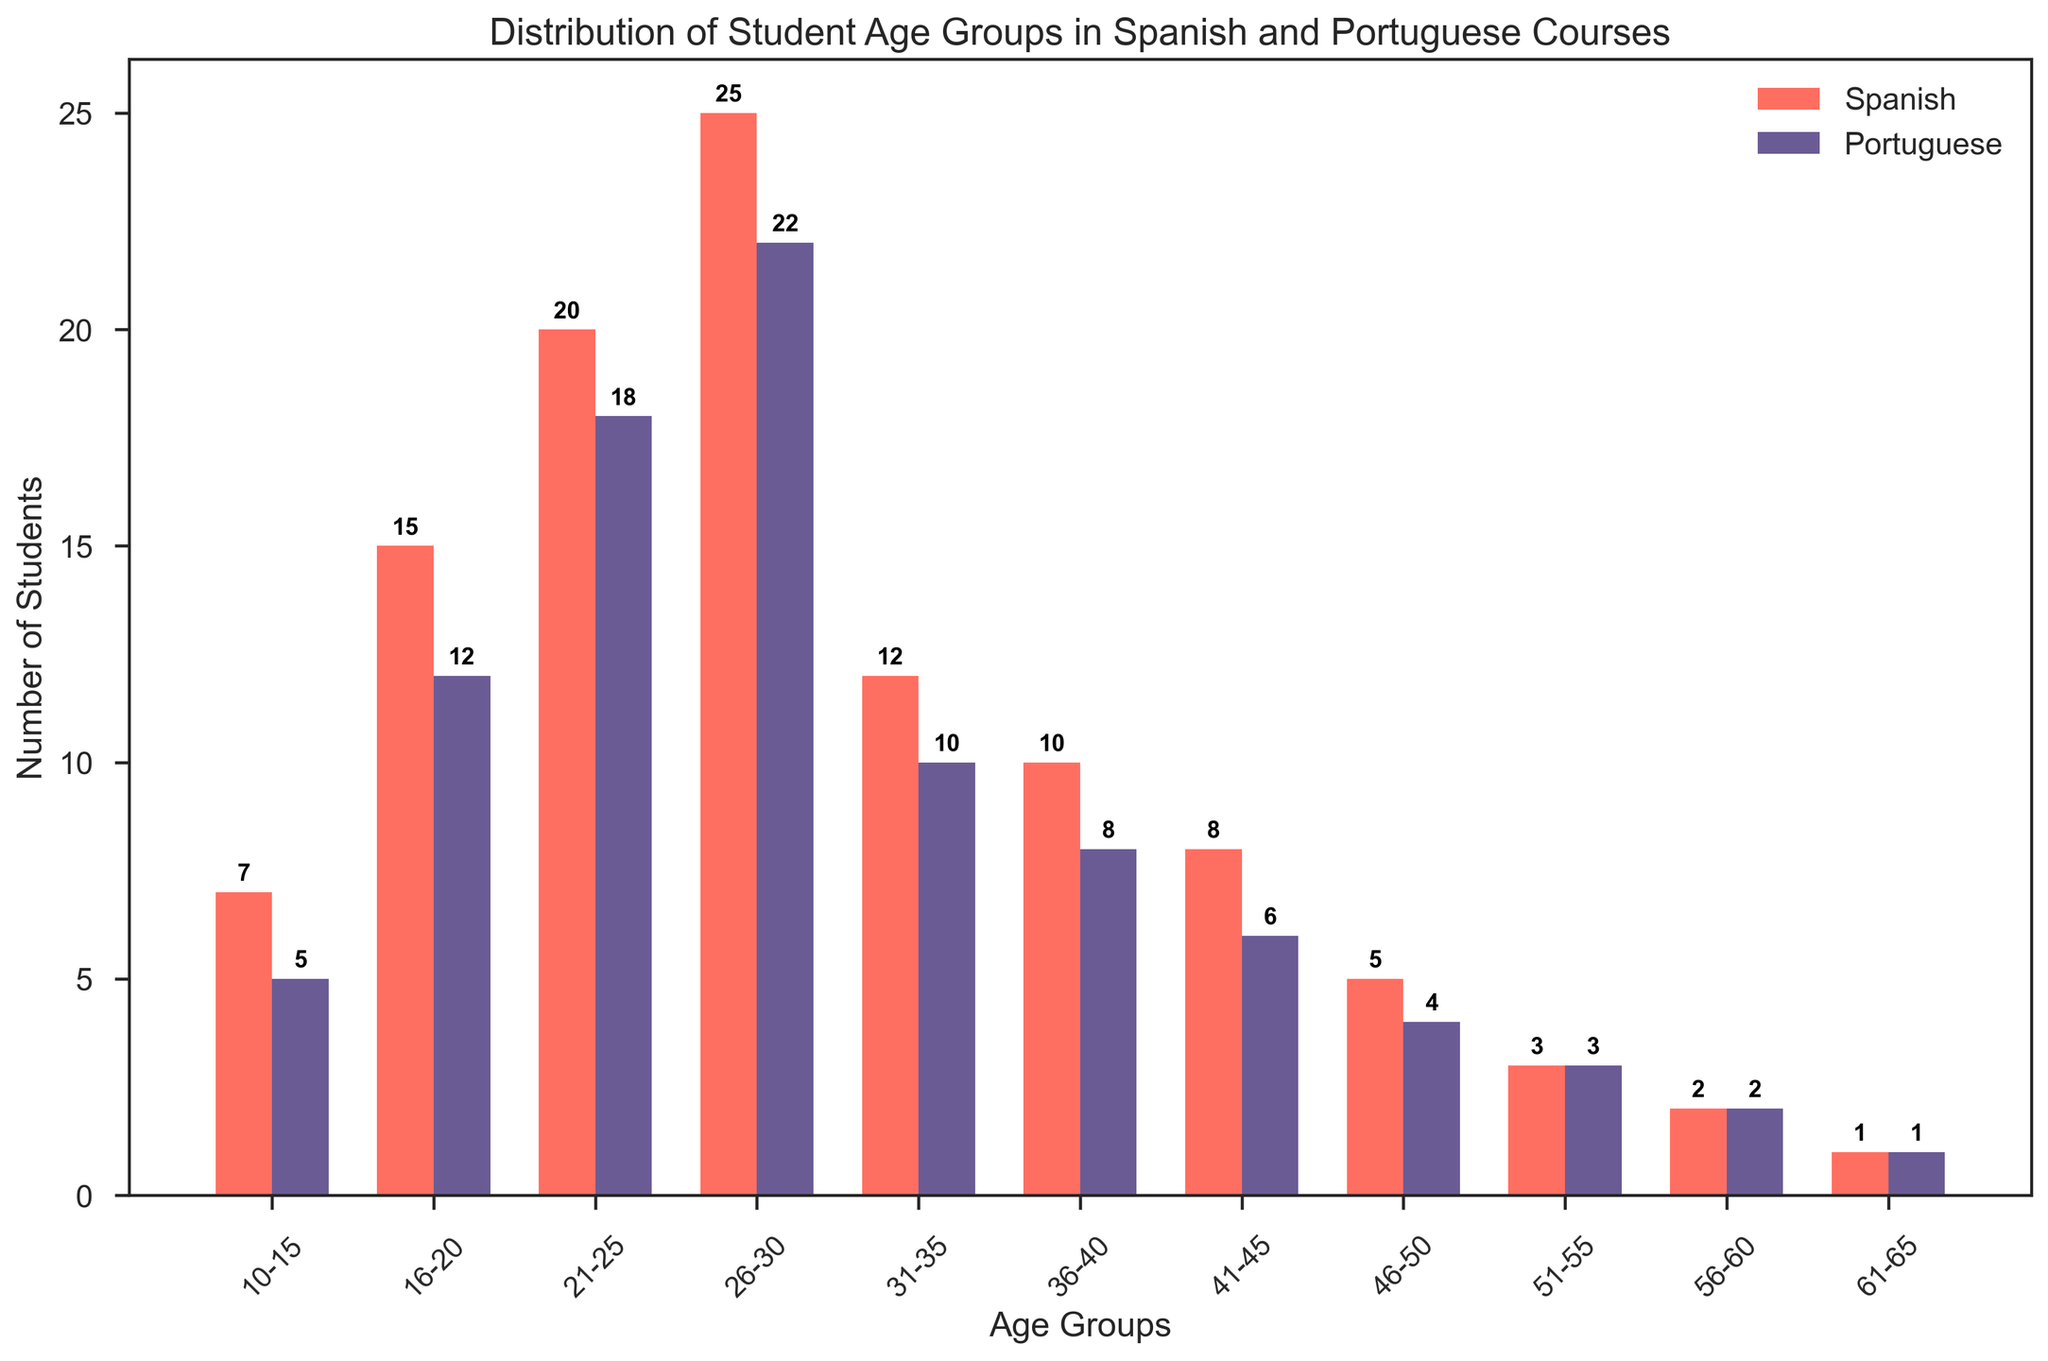Which age group has the highest number of students for Spanish courses? From the figure, the age group 26-30 has the highest bar among all the age groups for Spanish courses.
Answer: 26-30 Which age group has the highest number of students for Portuguese courses? From the figure, the age group 26-30 has the highest bar among all the age groups for Portuguese courses.
Answer: 26-30 Which age group has the smallest difference in the number of students between Spanish and Portuguese courses? From the figure, we check the height of the bars for both languages in each age group and find that the age group 56-60 has the smallest difference (both have 2 students).
Answer: 56-60 What is the total number of students enrolled in the age group 16-20 for both Spanish and Portuguese courses? Adding the number of students from both courses in the age group 16-20: 15 (Spanish) + 12 (Portuguese) = 27.
Answer: 27 Which age group shows the most dissimilarity in the number of students between the Spanish and Portuguese courses? By looking at the figure, the age group 26-30 has the largest difference, with Spanish (25 students) and Portuguese (22 students) having the highest and second-highest counts respectively.
Answer: 26-30 For which age groups do Spanish courses have more students than Portuguese courses? Spanish courses have more students than Portuguese in the following age groups: 10-15, 16-20, 21-25, 26-30, 31-35, 36-40, 41-45, and 46-50. This is inferred from their bars being taller.
Answer: 10-15, 16-20, 21-25, 26-30, 31-35, 36-40, 41-45, 46-50 What is the sum of students in Spanish courses across all age groups? Summing the number of students in Spanish courses across all age groups (7 + 15 + 20 + 25 + 12 + 10 + 8 + 5 + 3 + 2 + 1) = 108.
Answer: 108 What is the difference in the number of students between Spanish and Portuguese courses in the age group 31-35? Subtracting the number of Portuguese students from the Spanish students in the age group 31-35: 12 (Spanish) - 10 (Portuguese) = 2.
Answer: 2 Which language course has the overall higher enrollment in the age group 26-30? By comparing the heights of the bars, Spanish courses have higher enrollment (25 students) than Portuguese (22 students).
Answer: Spanish What is the average number of students in the age group 36-40 for both courses? Adding the number of students from both courses and dividing by 2: (10 (Spanish) + 8 (Portuguese)) / 2 = 9.
Answer: 9 